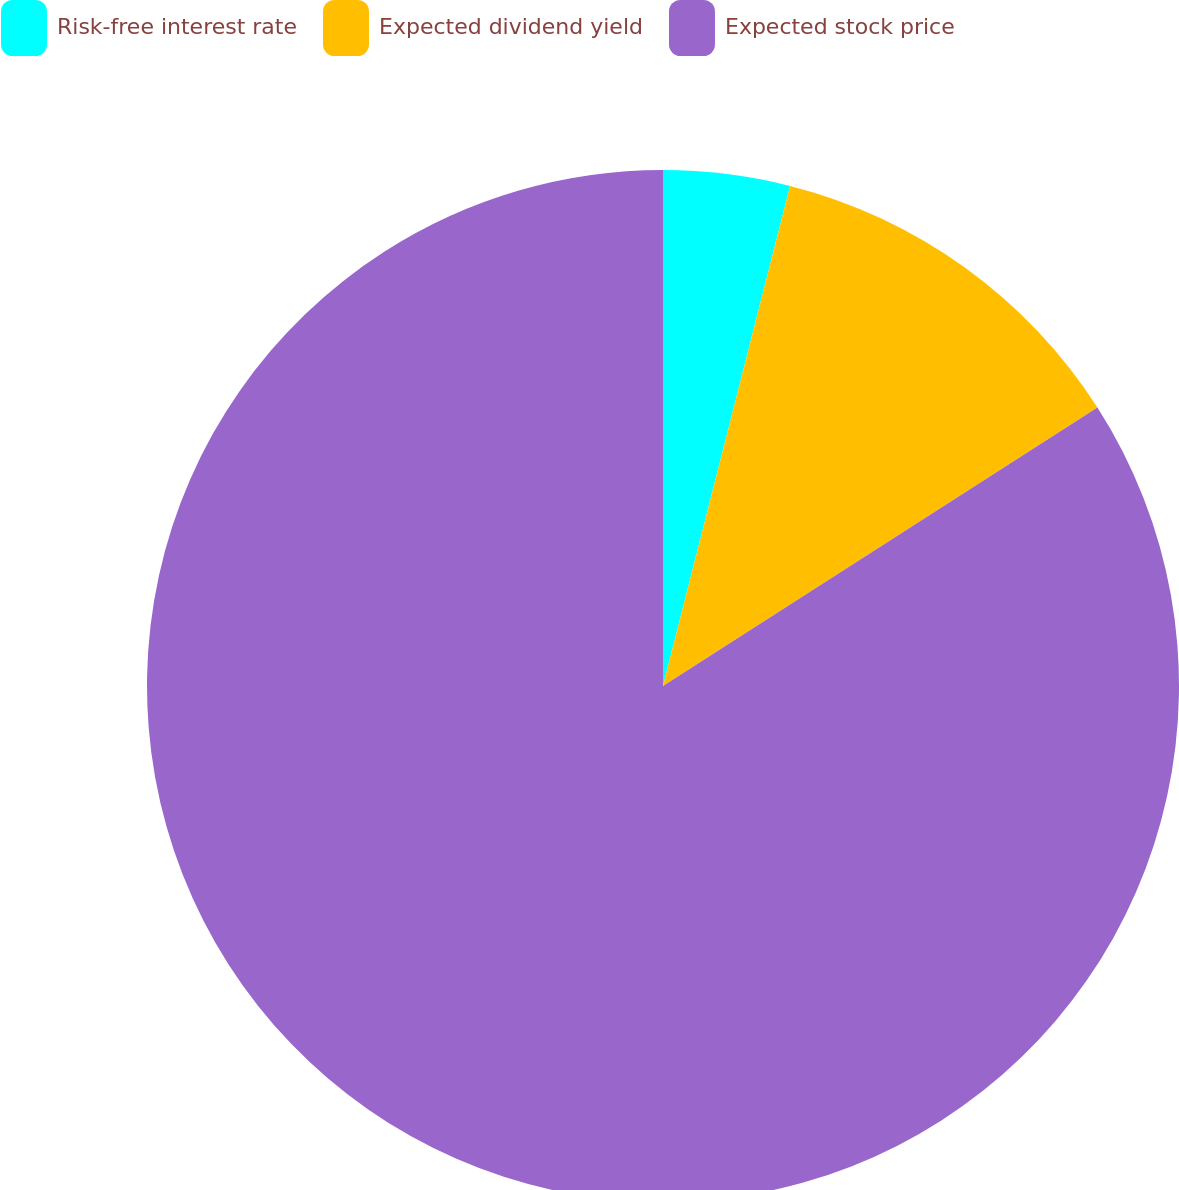Convert chart. <chart><loc_0><loc_0><loc_500><loc_500><pie_chart><fcel>Risk-free interest rate<fcel>Expected dividend yield<fcel>Expected stock price<nl><fcel>3.96%<fcel>11.97%<fcel>84.07%<nl></chart> 